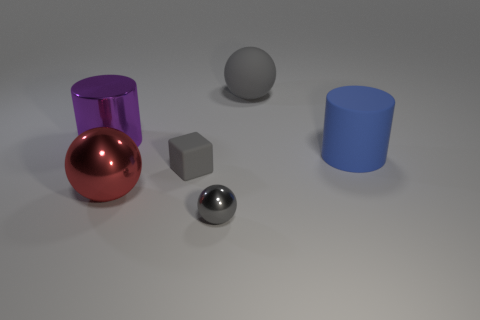Add 2 large purple cylinders. How many objects exist? 8 Subtract all cylinders. How many objects are left? 4 Add 1 red metal things. How many red metal things exist? 2 Subtract 0 green cylinders. How many objects are left? 6 Subtract all large red cylinders. Subtract all large purple metal cylinders. How many objects are left? 5 Add 3 spheres. How many spheres are left? 6 